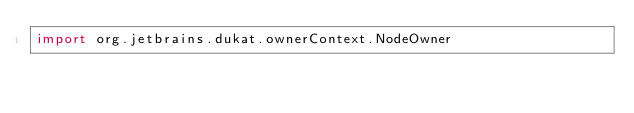Convert code to text. <code><loc_0><loc_0><loc_500><loc_500><_Kotlin_>import org.jetbrains.dukat.ownerContext.NodeOwner</code> 